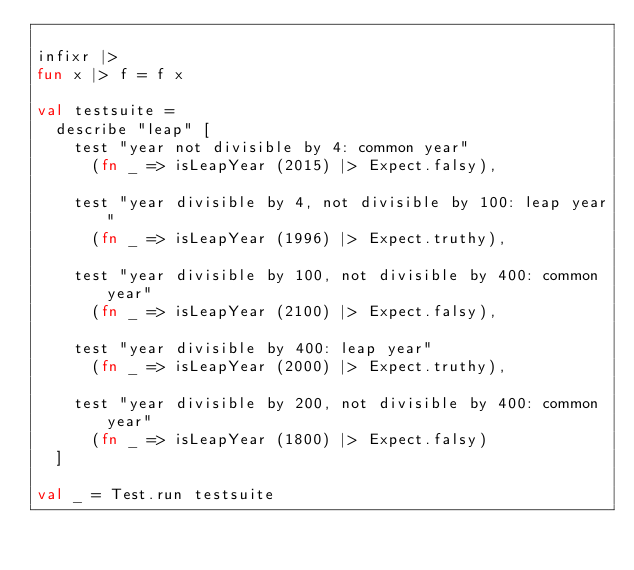Convert code to text. <code><loc_0><loc_0><loc_500><loc_500><_SML_>
infixr |>
fun x |> f = f x

val testsuite =
  describe "leap" [
    test "year not divisible by 4: common year"
      (fn _ => isLeapYear (2015) |> Expect.falsy),

    test "year divisible by 4, not divisible by 100: leap year"
      (fn _ => isLeapYear (1996) |> Expect.truthy),

    test "year divisible by 100, not divisible by 400: common year"
      (fn _ => isLeapYear (2100) |> Expect.falsy),

    test "year divisible by 400: leap year"
      (fn _ => isLeapYear (2000) |> Expect.truthy),

    test "year divisible by 200, not divisible by 400: common year"
      (fn _ => isLeapYear (1800) |> Expect.falsy)
  ]

val _ = Test.run testsuite
</code> 